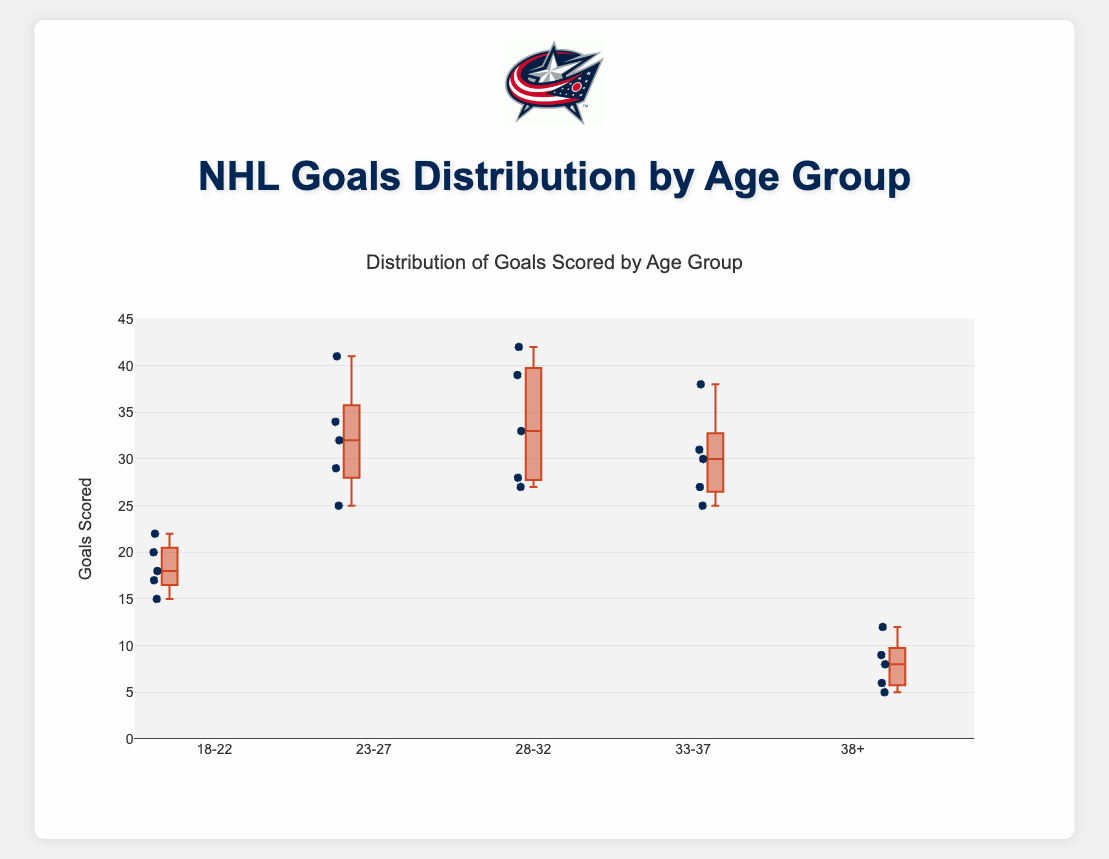What is the title of the figure? The title of a plot is usually placed at the top center. In this case, it is visually distinguishable by its font size and color.
Answer: Distribution of Goals Scored by Age Group How many goals did Cole Sillinger score? Locate the data point corresponding to Cole Sillinger in the box plot, which is under the "18-22" age group. Referencing the provided information, Cole Sillinger scored 20 goals.
Answer: 20 Which age group has the highest median number of goals? For this, we need to compare the median lines (usually the horizontal lines within the boxes) of each age group. The age group with the highest median line represents the group with the highest median number of goals.
Answer: 28-32 What is the interquartile range (IQR) for the "33-37" age group? The interquartile range (IQR) is calculated as the difference between the third quartile (75th percentile) and the first quartile (25th percentile) within the "33-37" age group box. Visually, this is the length of the box.
Answer: 31 - 27 = 4 How many players are in the "23-27" age group? Count the number of data points (individual dots) in the "23-27" age group section of the box plot. Given the provided data, there are 5 players in this age group: Auston Matthews, Patrik Laine, Mathew Barzal, Kyle Connor, and Tage Thompson.
Answer: 5 What is the range of goals scored by players aged 38+? The range is the difference between the maximum and minimum values in that group. In the "38+" age group, the maximum is 12 goals (Patrick Marleau) and the minimum is 5 goals (Keith Yandle).
Answer: 12 - 5 = 7 Which age group has the most variation in the number of goals scored? The age group with the largest IQR or the largest spread between the whiskers indicates the most variation. Visually, compare the lengths of the boxes and whiskers across age groups.
Answer: 28-32 Is there any age group where all players scored above 20 goals? Examine each age group's box and whisker plot to see if there are any data points below 20 goals. Based on the given data, none of the age groups have all players scoring above 20 goals.
Answer: No Which player in the "18-22" age group scored the most goals? From the data, find the player with the highest number of goals within the specified age group. Tim Stutzle scored the most goals in the "18-22" age group with 22 goals.
Answer: Tim Stutzle 